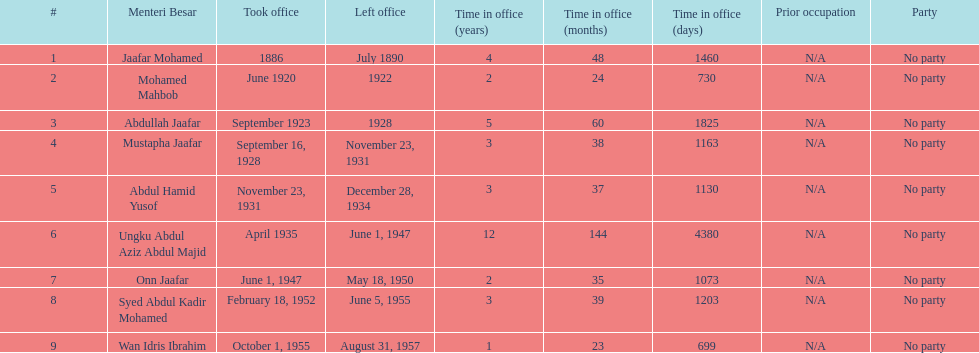Who was in office previous to abdullah jaafar? Mohamed Mahbob. 